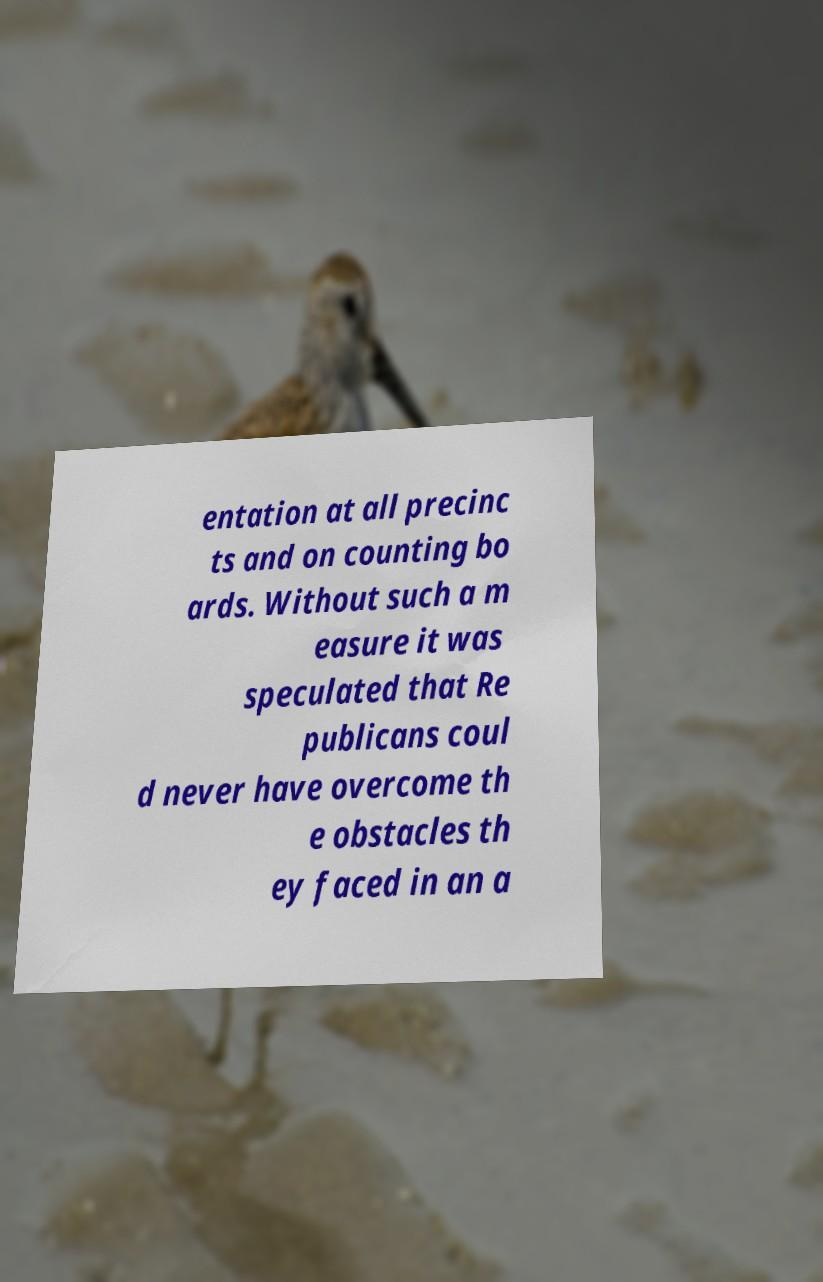Please read and relay the text visible in this image. What does it say? entation at all precinc ts and on counting bo ards. Without such a m easure it was speculated that Re publicans coul d never have overcome th e obstacles th ey faced in an a 